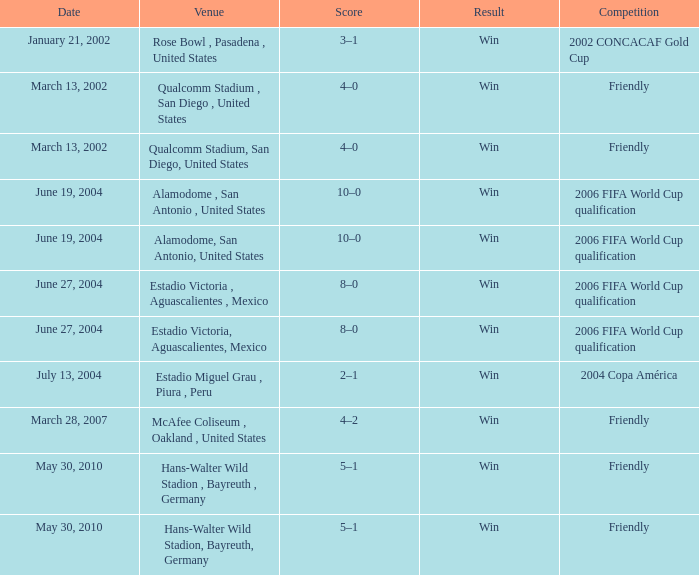What competition has June 19, 2004 as the date? 2006 FIFA World Cup qualification, 2006 FIFA World Cup qualification. 